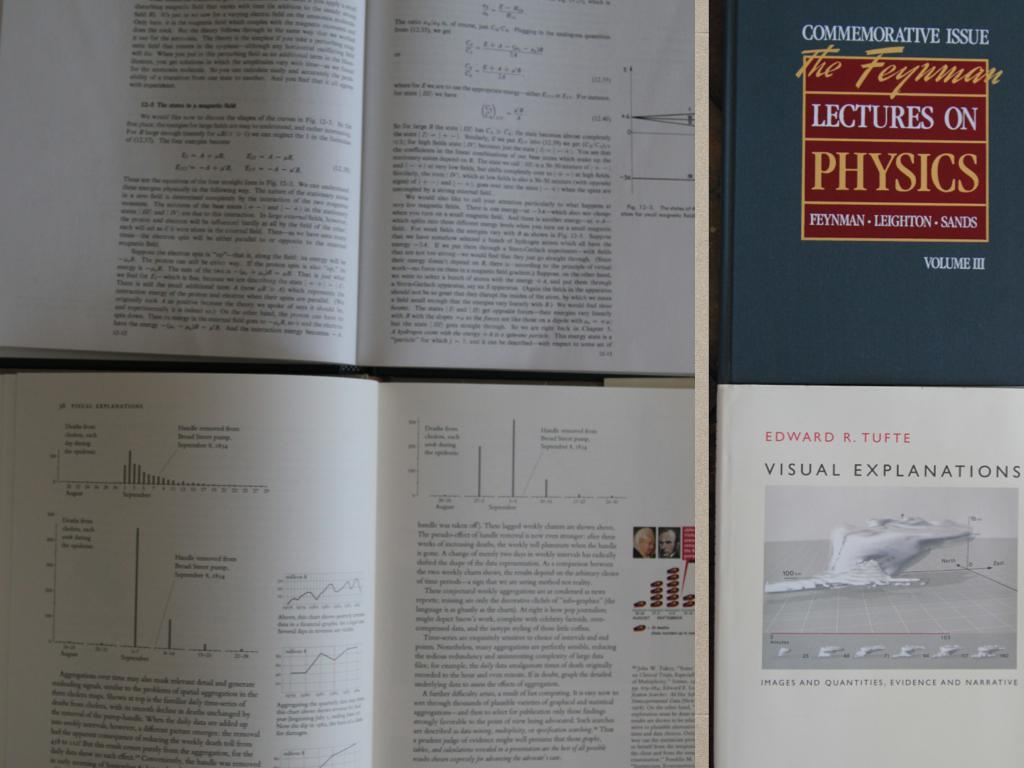<image>
Write a terse but informative summary of the picture. To opened books and two books not opened with one of the books cover says Lectures on Physics. 